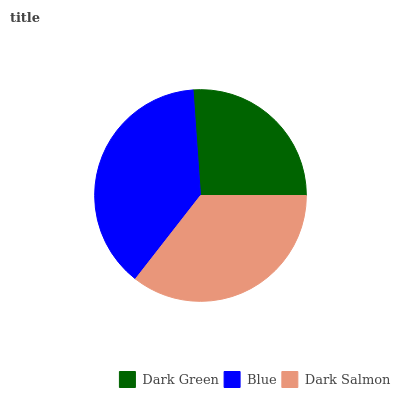Is Dark Green the minimum?
Answer yes or no. Yes. Is Blue the maximum?
Answer yes or no. Yes. Is Dark Salmon the minimum?
Answer yes or no. No. Is Dark Salmon the maximum?
Answer yes or no. No. Is Blue greater than Dark Salmon?
Answer yes or no. Yes. Is Dark Salmon less than Blue?
Answer yes or no. Yes. Is Dark Salmon greater than Blue?
Answer yes or no. No. Is Blue less than Dark Salmon?
Answer yes or no. No. Is Dark Salmon the high median?
Answer yes or no. Yes. Is Dark Salmon the low median?
Answer yes or no. Yes. Is Dark Green the high median?
Answer yes or no. No. Is Dark Green the low median?
Answer yes or no. No. 